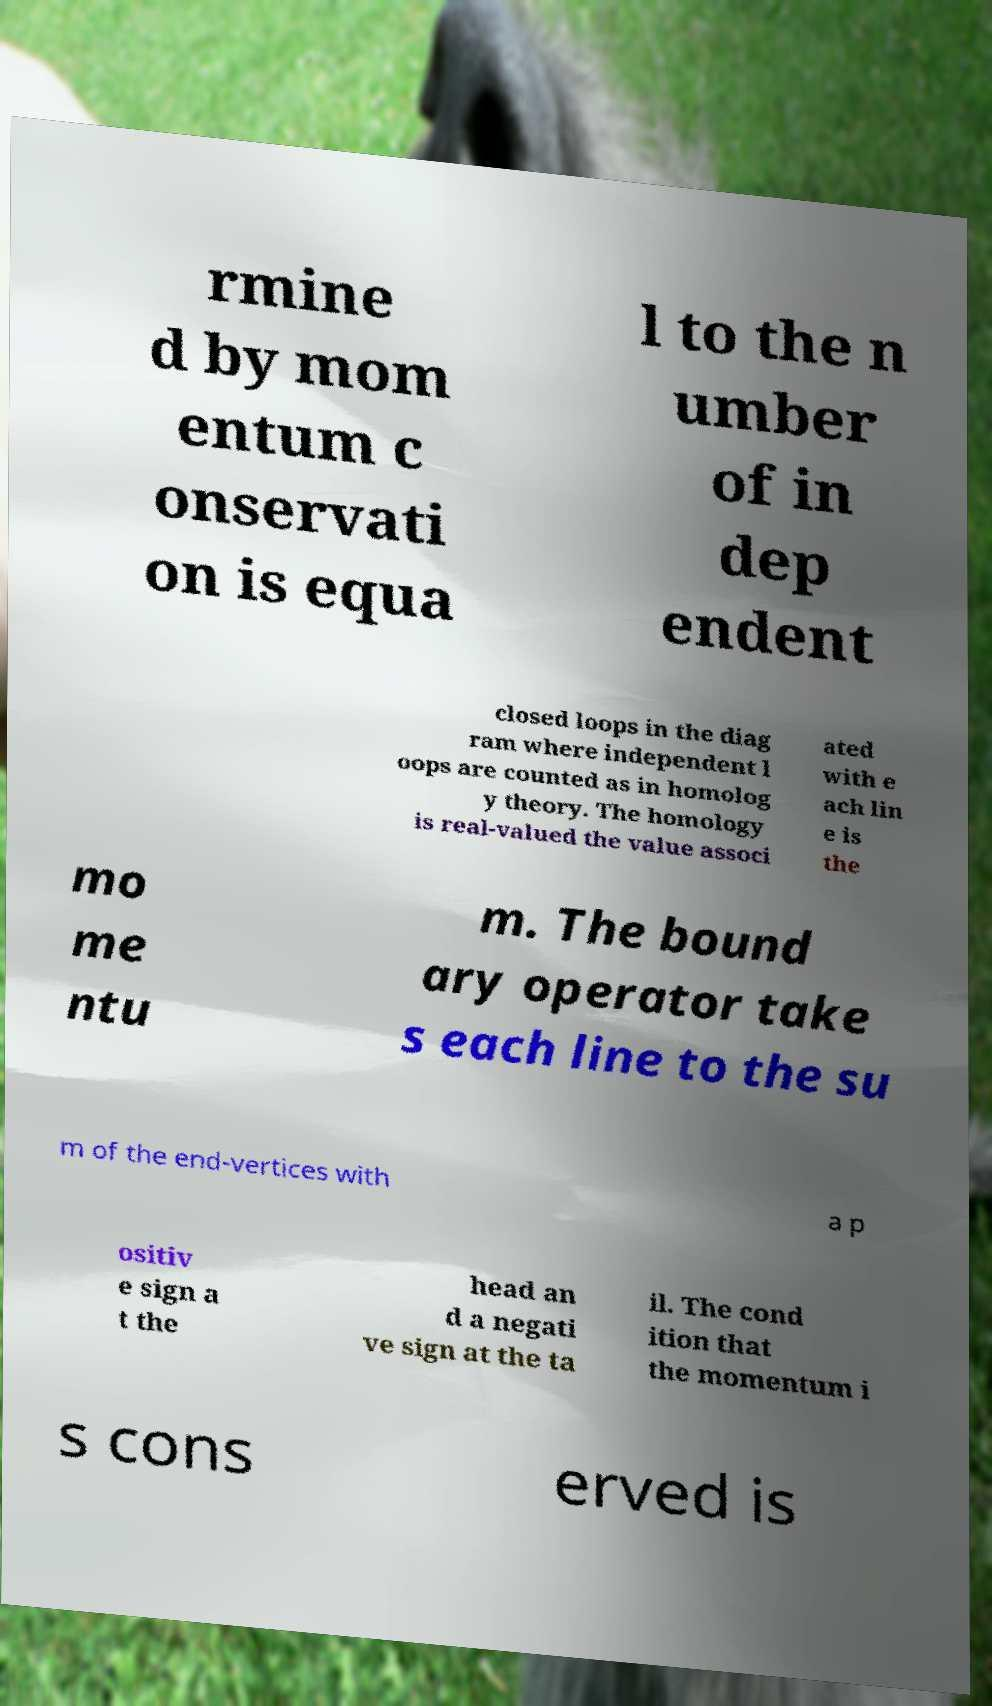Please read and relay the text visible in this image. What does it say? rmine d by mom entum c onservati on is equa l to the n umber of in dep endent closed loops in the diag ram where independent l oops are counted as in homolog y theory. The homology is real-valued the value associ ated with e ach lin e is the mo me ntu m. The bound ary operator take s each line to the su m of the end-vertices with a p ositiv e sign a t the head an d a negati ve sign at the ta il. The cond ition that the momentum i s cons erved is 